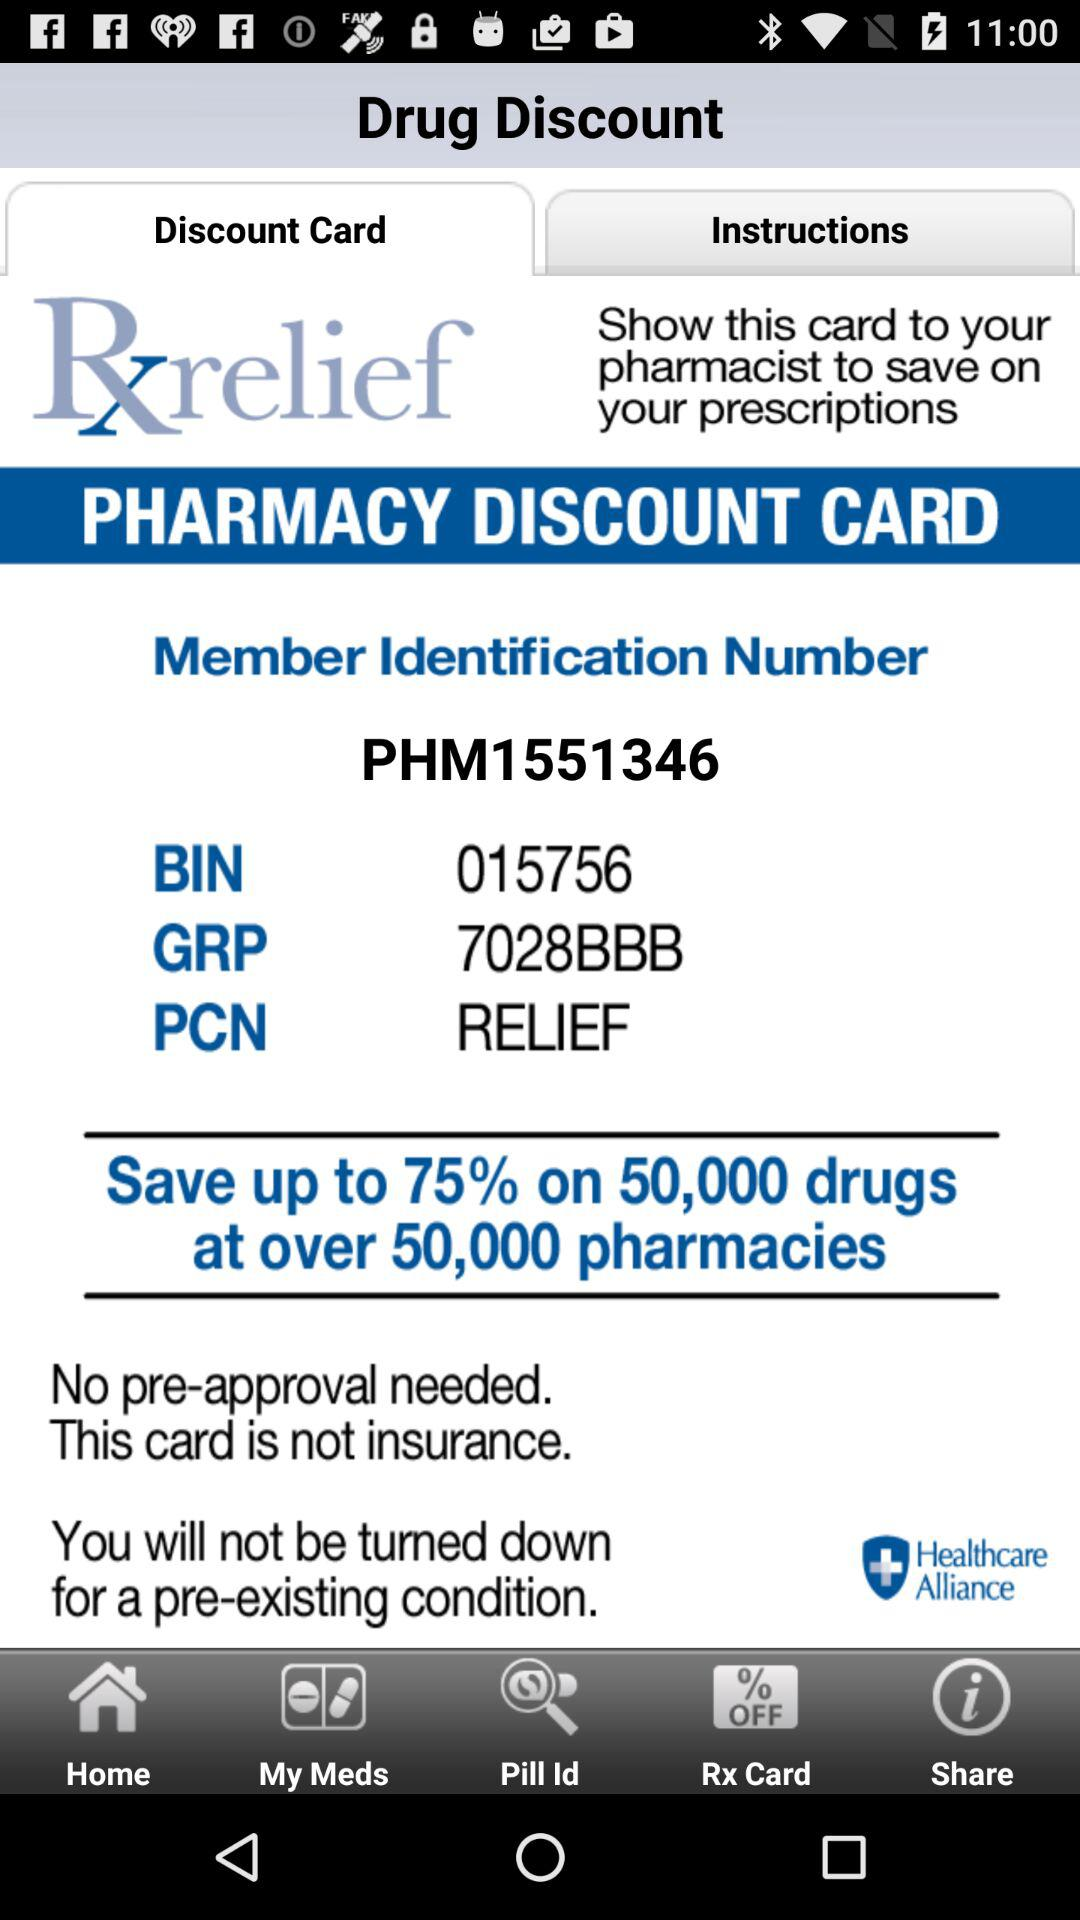What is the "GRP"? The "GRP" is 7028BBB. 